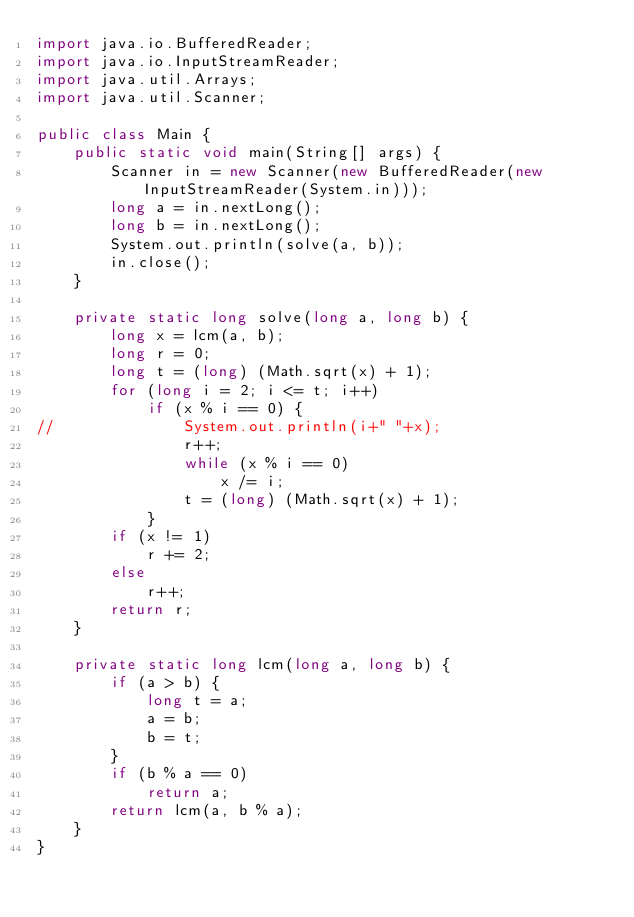<code> <loc_0><loc_0><loc_500><loc_500><_Java_>import java.io.BufferedReader;
import java.io.InputStreamReader;
import java.util.Arrays;
import java.util.Scanner;

public class Main {
	public static void main(String[] args) {
		Scanner in = new Scanner(new BufferedReader(new InputStreamReader(System.in)));
		long a = in.nextLong();
		long b = in.nextLong();
		System.out.println(solve(a, b));
		in.close();
	}

	private static long solve(long a, long b) {
		long x = lcm(a, b);
		long r = 0;
		long t = (long) (Math.sqrt(x) + 1);
		for (long i = 2; i <= t; i++)
			if (x % i == 0) {
//				System.out.println(i+" "+x);
				r++;
				while (x % i == 0)
					x /= i;
				t = (long) (Math.sqrt(x) + 1);
			}
		if (x != 1)
			r += 2;
		else
			r++;
		return r;
	}

	private static long lcm(long a, long b) {
		if (a > b) {
			long t = a;
			a = b;
			b = t;
		}
		if (b % a == 0)
			return a;
		return lcm(a, b % a);
	}
}
</code> 